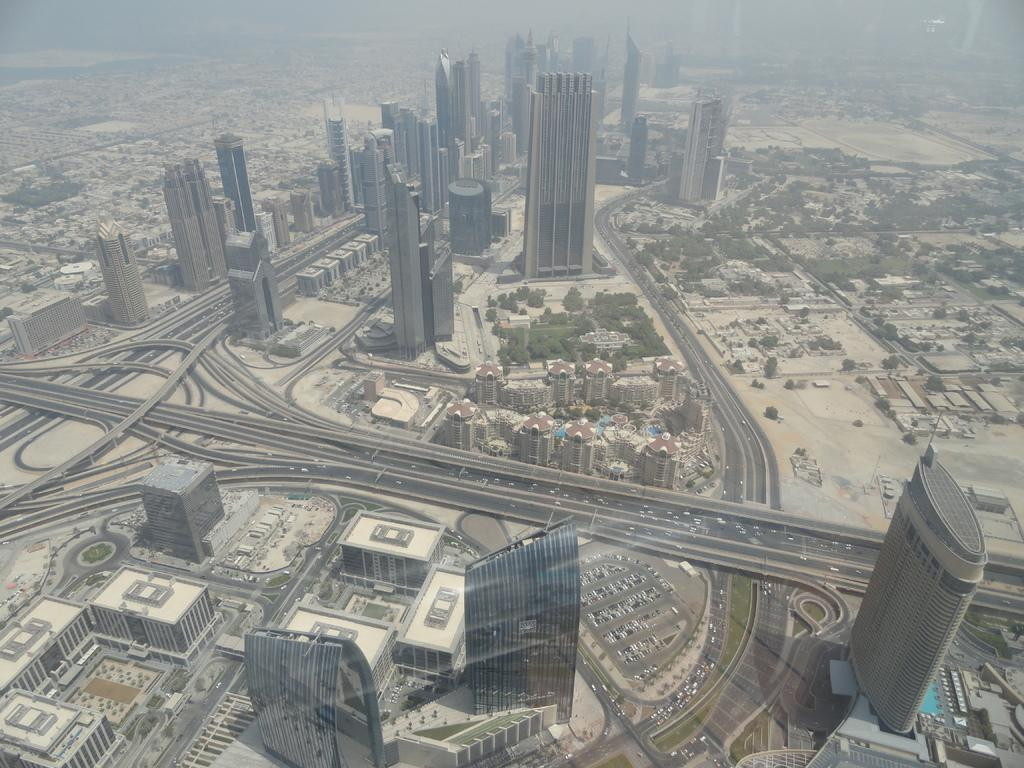What type of structures can be seen in the image? There are buildings in the image. What can be found between the buildings? There are roads in the image. Can you see any insects walking on the buildings in the image? There are no insects visible in the image, and therefore no such activity can be observed. 